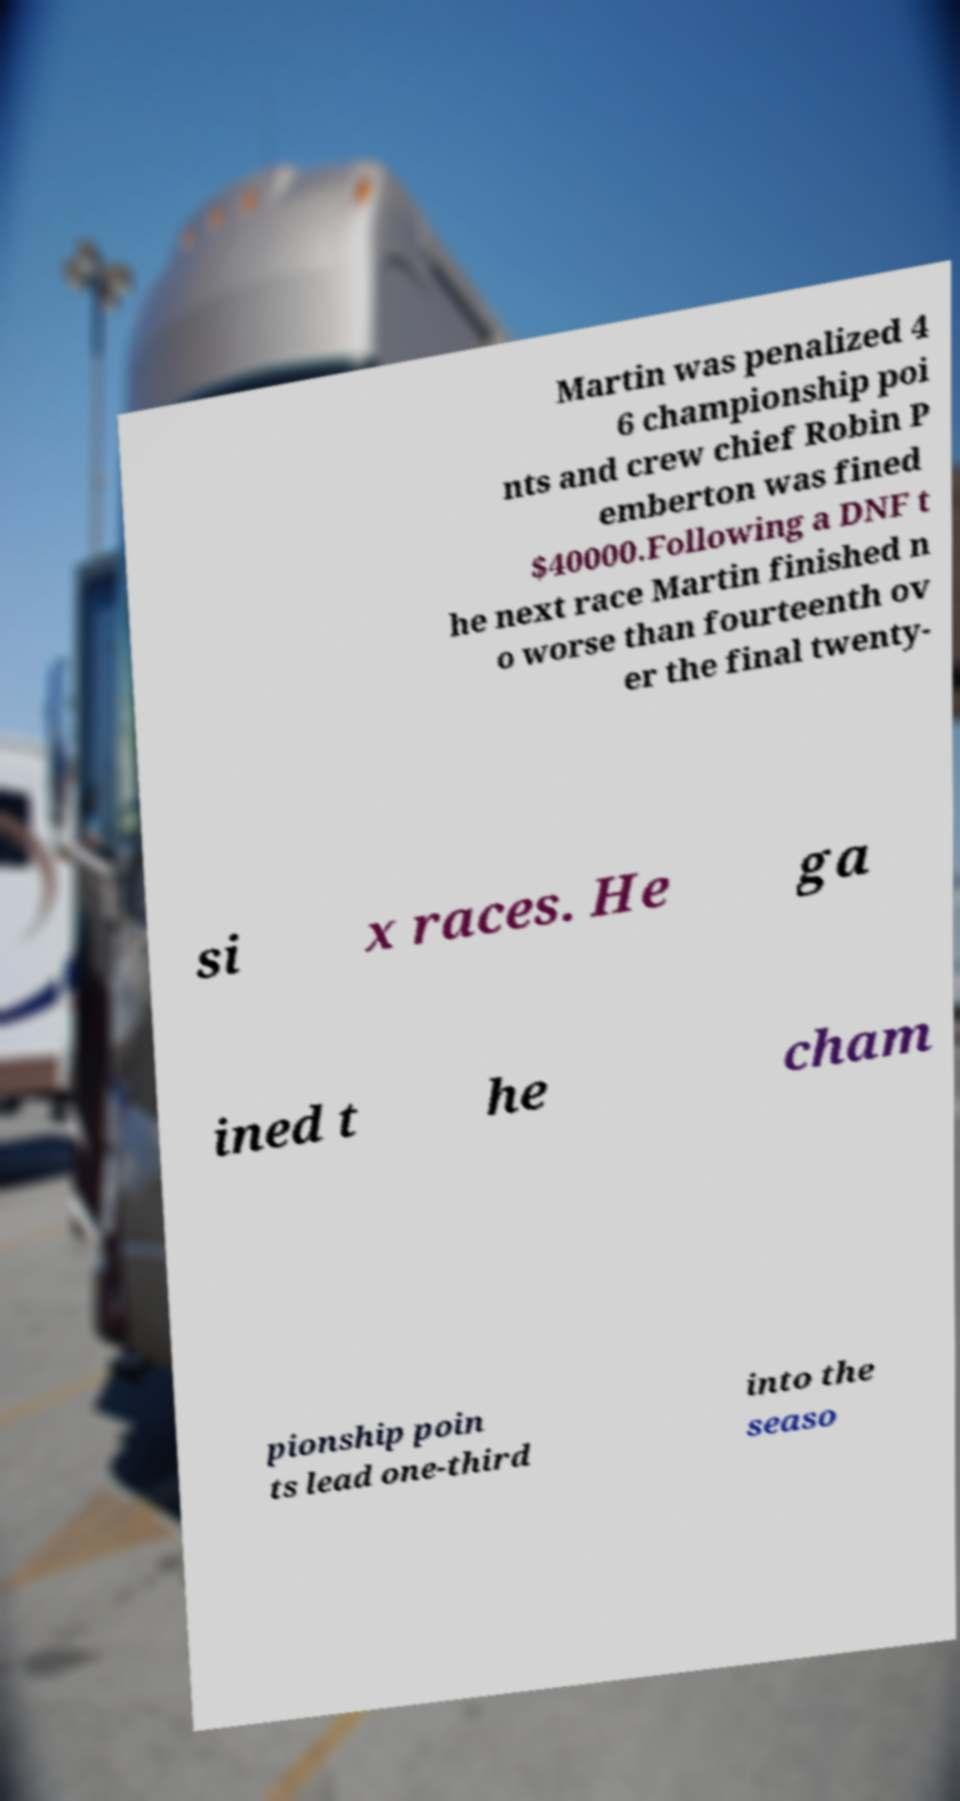I need the written content from this picture converted into text. Can you do that? Martin was penalized 4 6 championship poi nts and crew chief Robin P emberton was fined $40000.Following a DNF t he next race Martin finished n o worse than fourteenth ov er the final twenty- si x races. He ga ined t he cham pionship poin ts lead one-third into the seaso 